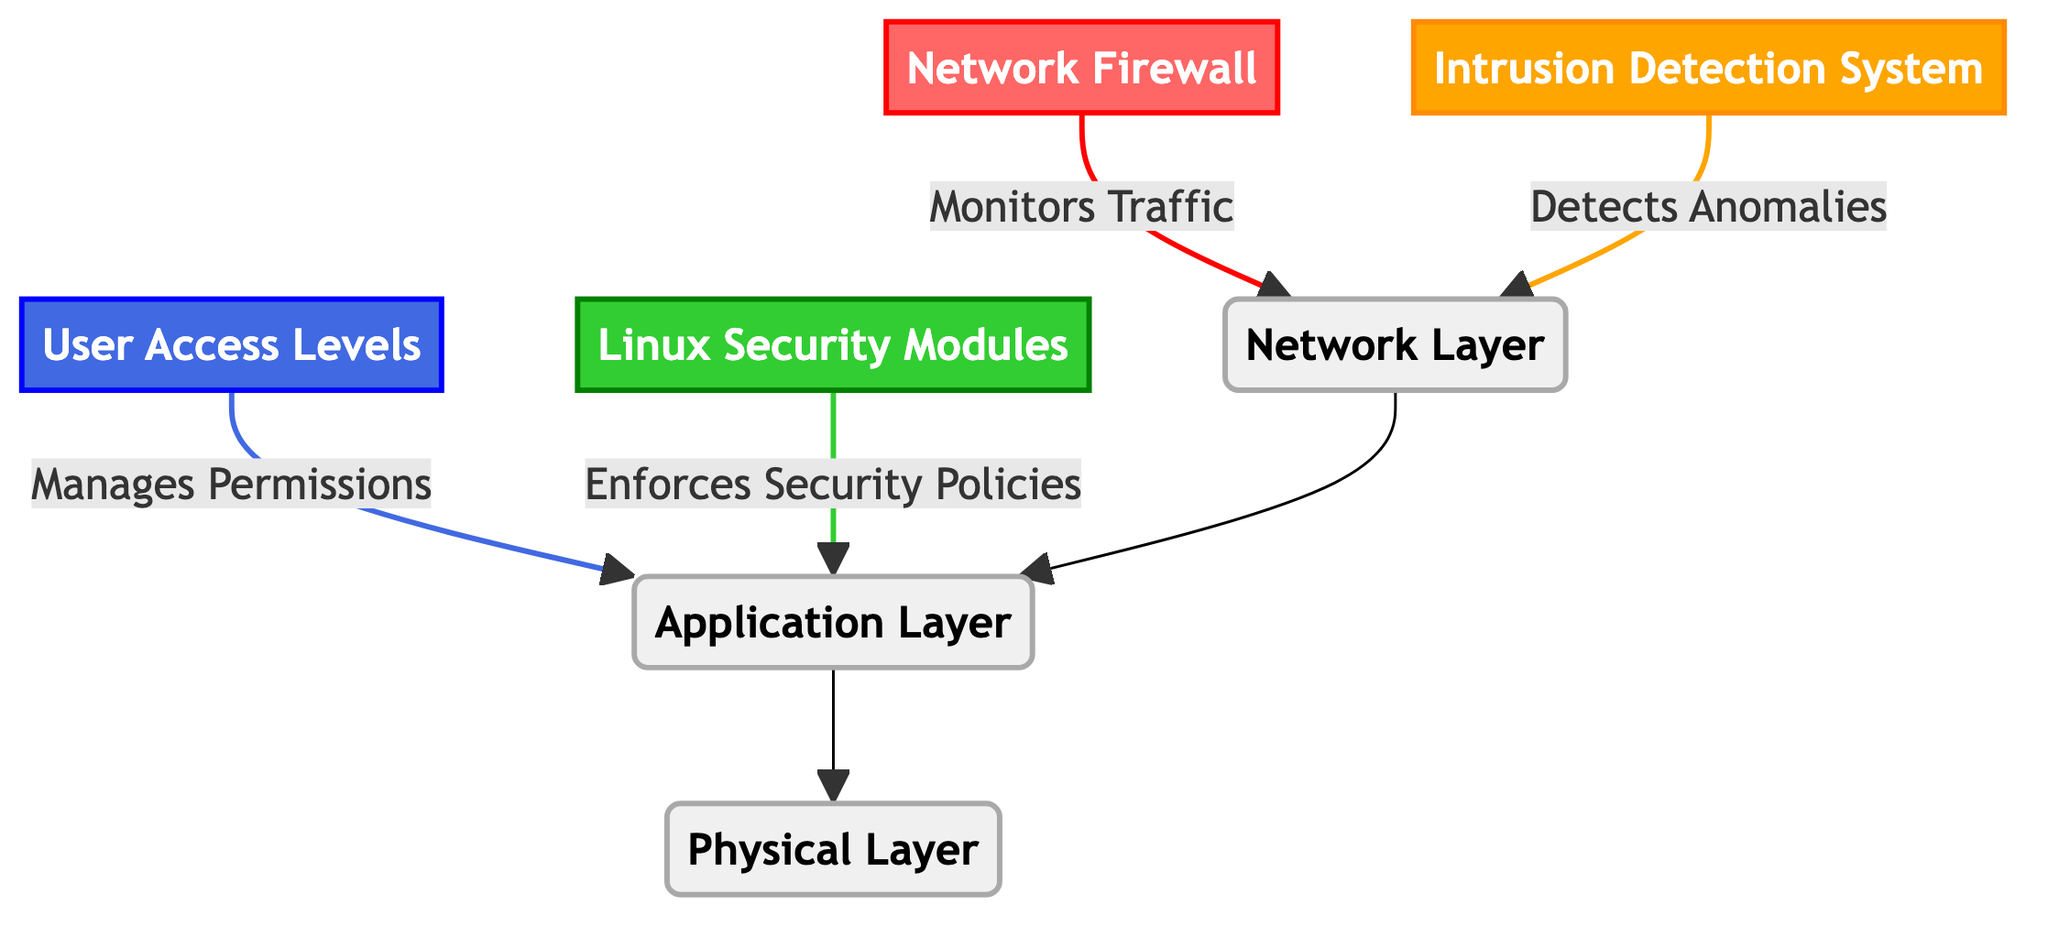What are the four main components in the diagram? The diagram contains four main components, which are the Network Firewall, Intrusion Detection System, User Access Levels, and Linux Security Modules. All these components are essential parts of the security architecture.
Answer: Network Firewall, Intrusion Detection System, User Access Levels, Linux Security Modules How many layers are represented in the diagram? The diagram shows three layers: Network Layer, Application Layer, and Physical Layer. These layers illustrate the various levels of security measures involved.
Answer: Three Which component is responsible for managing permissions? The component responsible for managing user permissions is the User Access Levels. It plays a key role in controlling access to resources and maintaining security.
Answer: User Access Levels What does the Intrusion Detection System detect? The Intrusion Detection System is responsible for detecting anomalies in network traffic. This allows it to identify potential security threats effectively.
Answer: Anomalies What type of security policy enforcement is indicated by the Linux Security Modules? The Linux Security Modules enforce security policies, which help protect the system by implementing rules and restrictions on access and behavior of users and applications.
Answer: Enforces Security Policies How does the Network Firewall interact with the Network Layer? The Network Firewall interacts with the Network Layer by monitoring traffic. It inspects incoming and outgoing data to prevent unauthorized access and attacks.
Answer: Monitors Traffic Which layers are connected to the Application Layer? The Application Layer is connected to the Network Layer and the Physical Layer. This connection shows how data flows from the network to the application and ultimately to the physical infrastructure.
Answer: Network Layer, Physical Layer What color represents the Linux Security Modules in the diagram? The Linux Security Modules are represented in green, which visually distinguishes it from the other components of the security architecture.
Answer: Green What type of diagram is this? This diagram is a Textbook Diagram, which is structured to visually represent different layers and components in a security architecture for Linux server infrastructure.
Answer: Textbook Diagram 